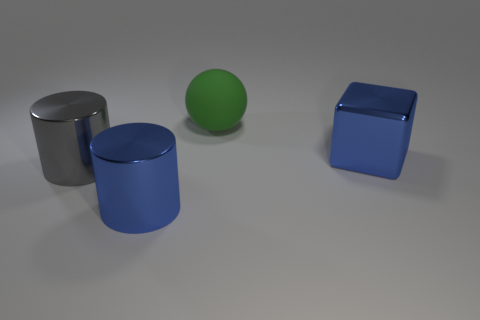Subtract all yellow cylinders. Subtract all cyan blocks. How many cylinders are left? 2 Add 3 big balls. How many objects exist? 7 Subtract all blocks. How many objects are left? 3 Subtract 0 cyan blocks. How many objects are left? 4 Subtract all big blue metallic things. Subtract all gray cylinders. How many objects are left? 1 Add 4 big objects. How many big objects are left? 8 Add 2 small red objects. How many small red objects exist? 2 